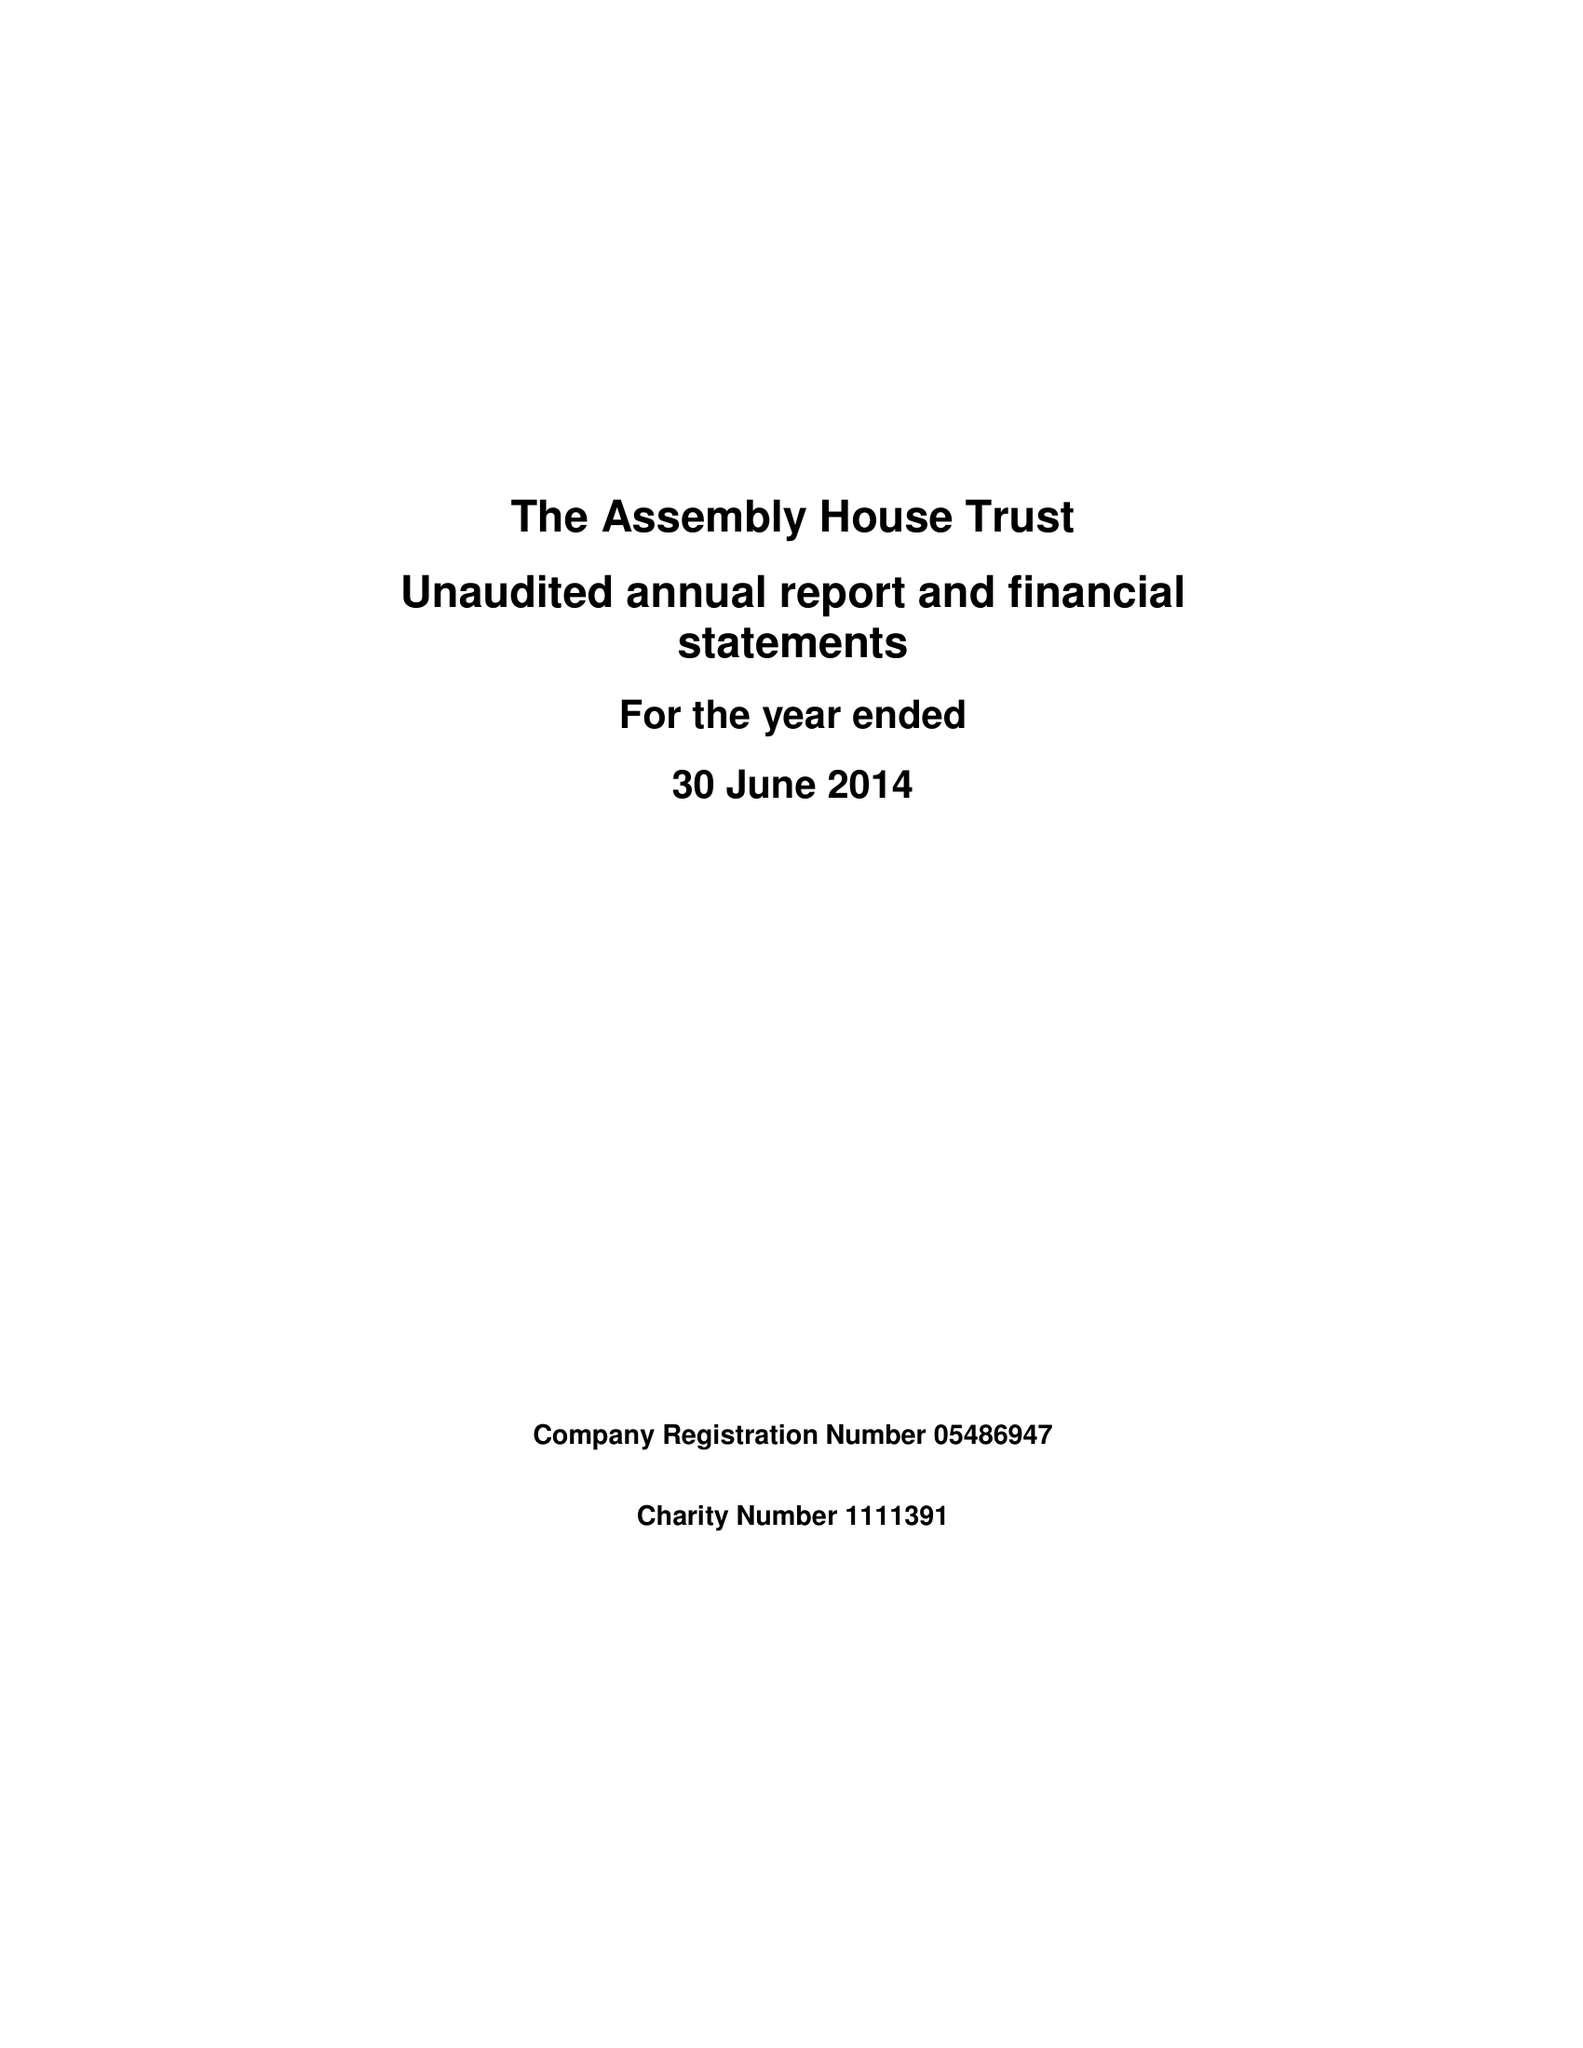What is the value for the address__postcode?
Answer the question using a single word or phrase. NR2 1RQ 